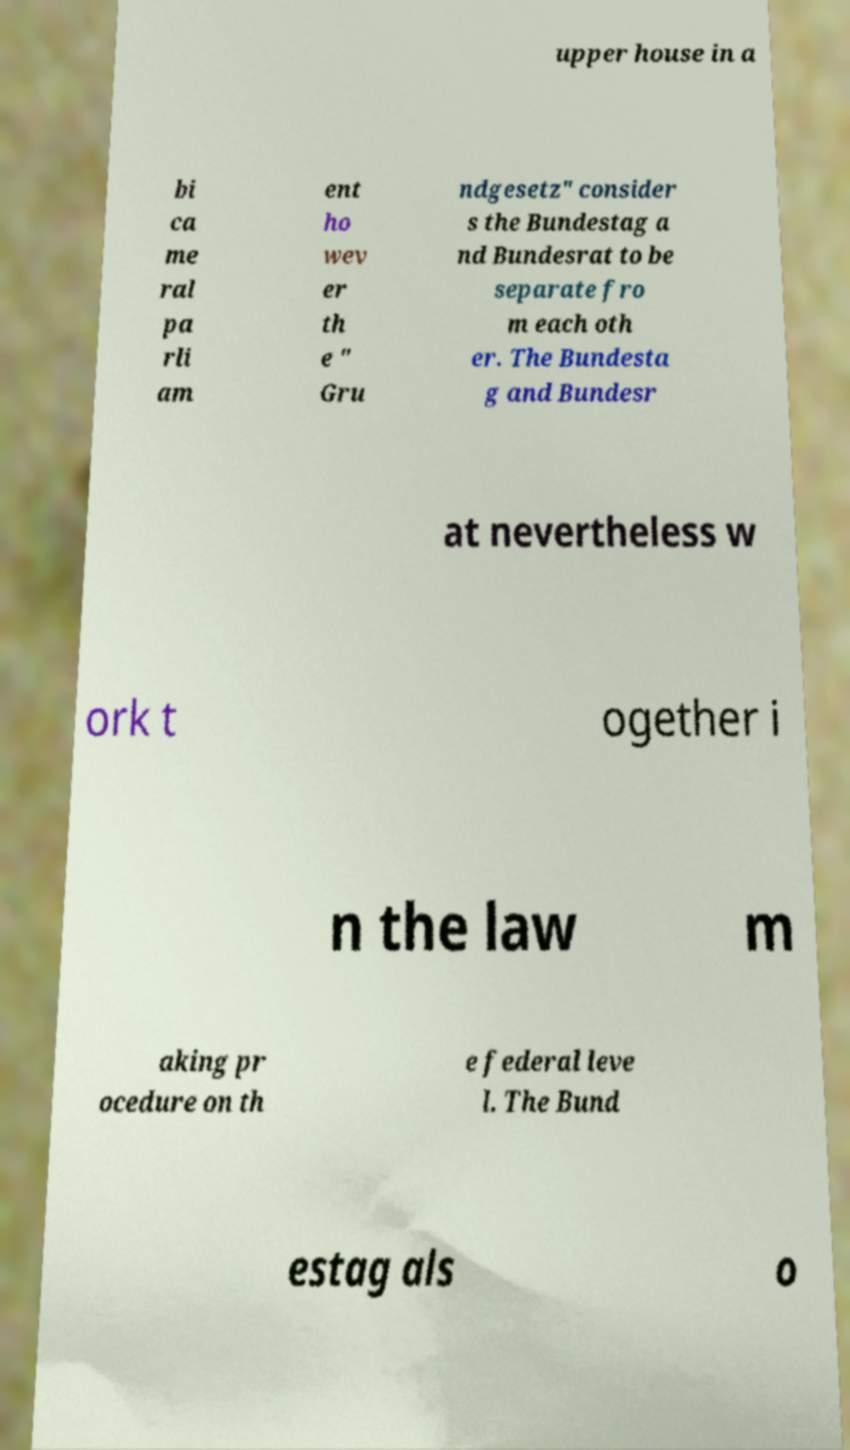There's text embedded in this image that I need extracted. Can you transcribe it verbatim? upper house in a bi ca me ral pa rli am ent ho wev er th e " Gru ndgesetz" consider s the Bundestag a nd Bundesrat to be separate fro m each oth er. The Bundesta g and Bundesr at nevertheless w ork t ogether i n the law m aking pr ocedure on th e federal leve l. The Bund estag als o 